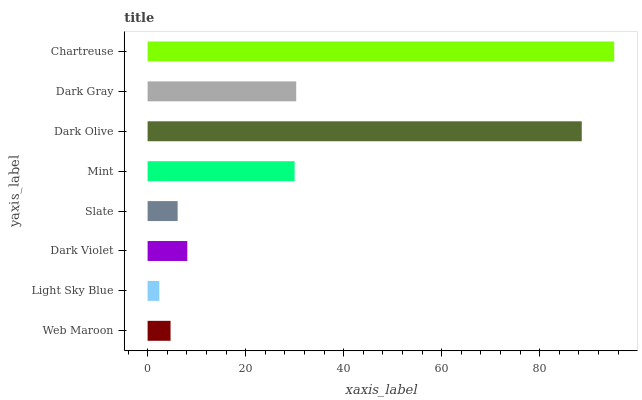Is Light Sky Blue the minimum?
Answer yes or no. Yes. Is Chartreuse the maximum?
Answer yes or no. Yes. Is Dark Violet the minimum?
Answer yes or no. No. Is Dark Violet the maximum?
Answer yes or no. No. Is Dark Violet greater than Light Sky Blue?
Answer yes or no. Yes. Is Light Sky Blue less than Dark Violet?
Answer yes or no. Yes. Is Light Sky Blue greater than Dark Violet?
Answer yes or no. No. Is Dark Violet less than Light Sky Blue?
Answer yes or no. No. Is Mint the high median?
Answer yes or no. Yes. Is Dark Violet the low median?
Answer yes or no. Yes. Is Dark Violet the high median?
Answer yes or no. No. Is Web Maroon the low median?
Answer yes or no. No. 